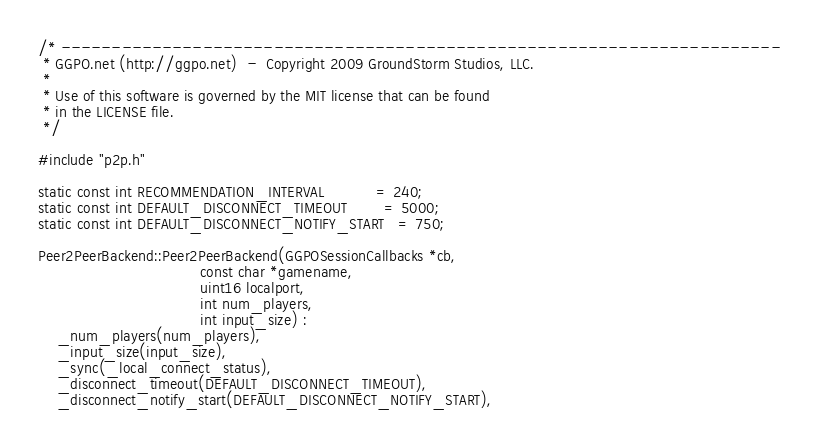<code> <loc_0><loc_0><loc_500><loc_500><_C++_>/* -----------------------------------------------------------------------
 * GGPO.net (http://ggpo.net)  -  Copyright 2009 GroundStorm Studios, LLC.
 *
 * Use of this software is governed by the MIT license that can be found
 * in the LICENSE file.
 */

#include "p2p.h"

static const int RECOMMENDATION_INTERVAL           = 240;
static const int DEFAULT_DISCONNECT_TIMEOUT        = 5000;
static const int DEFAULT_DISCONNECT_NOTIFY_START   = 750;

Peer2PeerBackend::Peer2PeerBackend(GGPOSessionCallbacks *cb,
                                   const char *gamename,
                                   uint16 localport,
                                   int num_players,
                                   int input_size) :
    _num_players(num_players),
    _input_size(input_size),
    _sync(_local_connect_status),
    _disconnect_timeout(DEFAULT_DISCONNECT_TIMEOUT),
    _disconnect_notify_start(DEFAULT_DISCONNECT_NOTIFY_START),</code> 